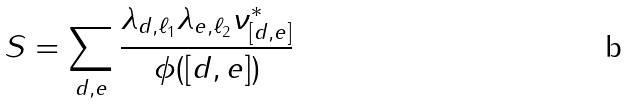<formula> <loc_0><loc_0><loc_500><loc_500>S = \sum _ { d , e } \frac { \lambda _ { d , \ell _ { 1 } } \lambda _ { e , \ell _ { 2 } } \nu ^ { * } _ { [ d , e ] } } { \phi ( [ d , e ] ) }</formula> 